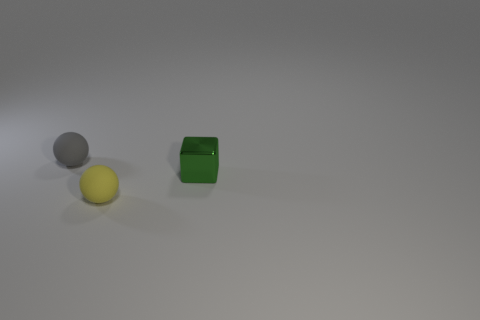Add 2 large gray metallic cylinders. How many objects exist? 5 Subtract all balls. How many objects are left? 1 Subtract 0 blue balls. How many objects are left? 3 Subtract 2 balls. How many balls are left? 0 Subtract all yellow balls. Subtract all cyan cubes. How many balls are left? 1 Subtract all green blocks. Subtract all rubber things. How many objects are left? 0 Add 1 gray things. How many gray things are left? 2 Add 1 big purple cylinders. How many big purple cylinders exist? 1 